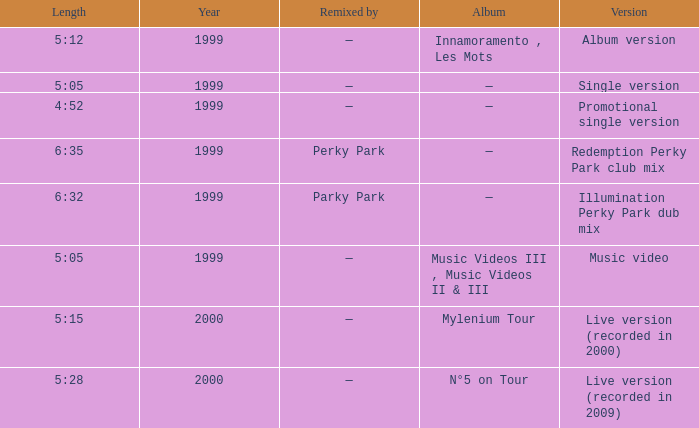What album is 5:15 long Live version (recorded in 2000). 